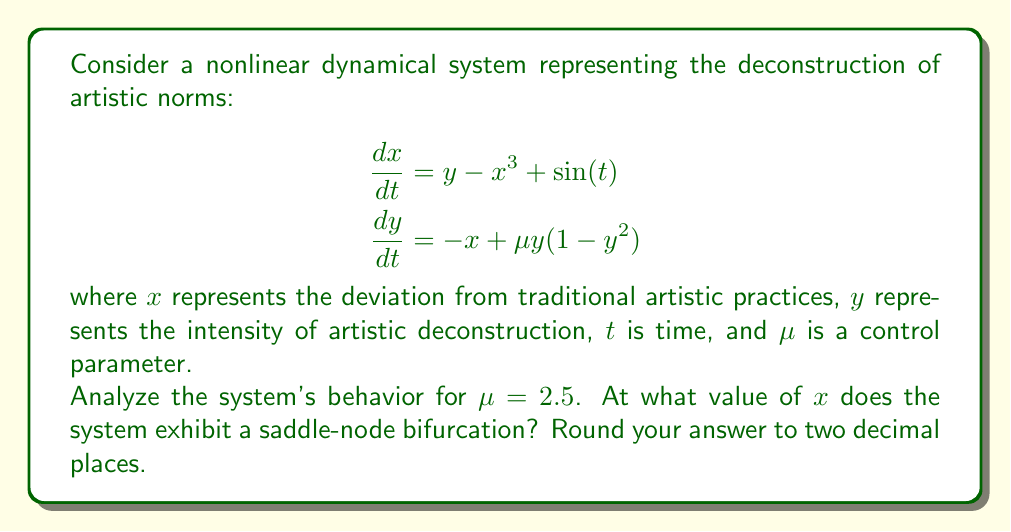Provide a solution to this math problem. To find the saddle-node bifurcation point, we need to follow these steps:

1) First, we find the fixed points of the system by setting the time derivatives to zero:

   $$\begin{aligned}
   0 &= y - x^3 + \sin(t) \\
   0 &= -x + \mu y(1-y^2)
   \end{aligned}$$

2) Since we're looking for time-independent solutions, we can set $\sin(t) = 0$. This gives:

   $$\begin{aligned}
   y &= x^3 \\
   x &= \mu y(1-y^2)
   \end{aligned}$$

3) Substituting the first equation into the second:

   $$x = \mu x^3(1-x^6)$$

4) Rearranging:

   $$x[\mu(1-x^6) - x^2] = 0$$

5) The saddle-node bifurcation occurs when this equation has a double root. This happens when both the function and its derivative are zero:

   $$\mu(1-x^6) - x^2 = 0$$
   $$-6\mu x^5 - 2x = 0$$

6) From the second equation:

   $$x(-6\mu x^4 - 2) = 0$$

   The non-zero solution is when:

   $$-6\mu x^4 - 2 = 0$$
   $$x^4 = -\frac{1}{3\mu}$$

7) Substituting $\mu = 2.5$:

   $$x^4 = -\frac{1}{7.5} = -0.1333...$$

8) Taking the fourth root:

   $$x = \pm \sqrt[4]{0.1333...} \approx \pm 0.6043$$

9) We take the positive value as our solution.
Answer: 0.60 